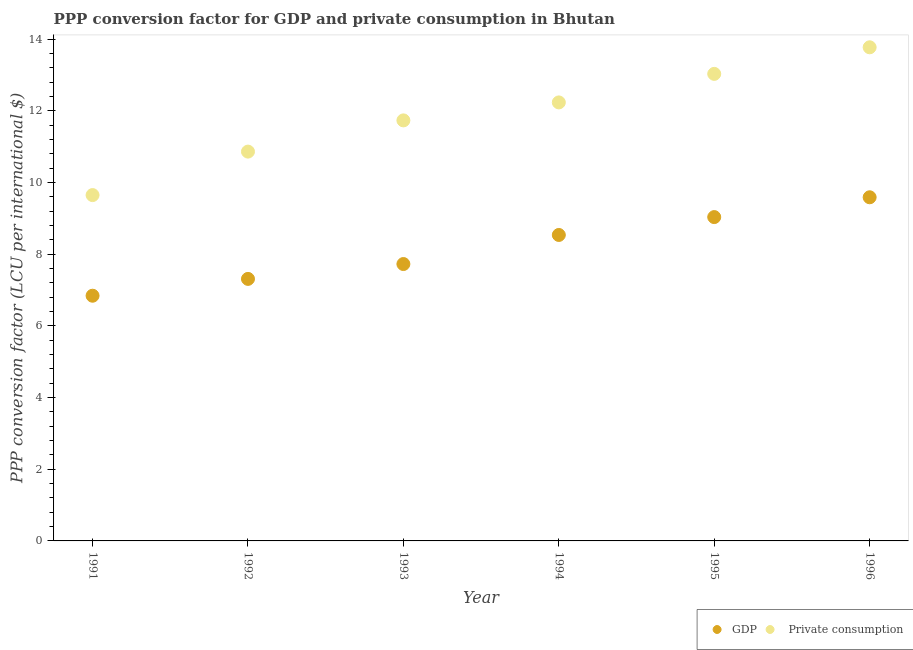How many different coloured dotlines are there?
Ensure brevity in your answer.  2. What is the ppp conversion factor for private consumption in 1994?
Offer a very short reply. 12.24. Across all years, what is the maximum ppp conversion factor for gdp?
Offer a very short reply. 9.59. Across all years, what is the minimum ppp conversion factor for gdp?
Offer a very short reply. 6.84. In which year was the ppp conversion factor for private consumption maximum?
Your response must be concise. 1996. What is the total ppp conversion factor for private consumption in the graph?
Ensure brevity in your answer.  71.3. What is the difference between the ppp conversion factor for private consumption in 1991 and that in 1993?
Keep it short and to the point. -2.08. What is the difference between the ppp conversion factor for gdp in 1995 and the ppp conversion factor for private consumption in 1992?
Give a very brief answer. -1.83. What is the average ppp conversion factor for gdp per year?
Make the answer very short. 8.17. In the year 1995, what is the difference between the ppp conversion factor for gdp and ppp conversion factor for private consumption?
Make the answer very short. -4. What is the ratio of the ppp conversion factor for gdp in 1992 to that in 1995?
Make the answer very short. 0.81. Is the ppp conversion factor for private consumption in 1993 less than that in 1996?
Provide a succinct answer. Yes. Is the difference between the ppp conversion factor for gdp in 1991 and 1993 greater than the difference between the ppp conversion factor for private consumption in 1991 and 1993?
Give a very brief answer. Yes. What is the difference between the highest and the second highest ppp conversion factor for gdp?
Offer a very short reply. 0.55. What is the difference between the highest and the lowest ppp conversion factor for private consumption?
Your answer should be compact. 4.12. In how many years, is the ppp conversion factor for gdp greater than the average ppp conversion factor for gdp taken over all years?
Ensure brevity in your answer.  3. Is the sum of the ppp conversion factor for gdp in 1993 and 1994 greater than the maximum ppp conversion factor for private consumption across all years?
Make the answer very short. Yes. Does the ppp conversion factor for gdp monotonically increase over the years?
Offer a terse response. Yes. Are the values on the major ticks of Y-axis written in scientific E-notation?
Provide a short and direct response. No. Does the graph contain any zero values?
Provide a short and direct response. No. Does the graph contain grids?
Provide a short and direct response. No. What is the title of the graph?
Your answer should be compact. PPP conversion factor for GDP and private consumption in Bhutan. What is the label or title of the X-axis?
Provide a short and direct response. Year. What is the label or title of the Y-axis?
Your response must be concise. PPP conversion factor (LCU per international $). What is the PPP conversion factor (LCU per international $) in GDP in 1991?
Provide a short and direct response. 6.84. What is the PPP conversion factor (LCU per international $) in  Private consumption in 1991?
Your answer should be very brief. 9.65. What is the PPP conversion factor (LCU per international $) in GDP in 1992?
Your answer should be compact. 7.31. What is the PPP conversion factor (LCU per international $) of  Private consumption in 1992?
Your response must be concise. 10.86. What is the PPP conversion factor (LCU per international $) of GDP in 1993?
Offer a terse response. 7.73. What is the PPP conversion factor (LCU per international $) of  Private consumption in 1993?
Offer a very short reply. 11.74. What is the PPP conversion factor (LCU per international $) of GDP in 1994?
Keep it short and to the point. 8.54. What is the PPP conversion factor (LCU per international $) of  Private consumption in 1994?
Provide a succinct answer. 12.24. What is the PPP conversion factor (LCU per international $) of GDP in 1995?
Make the answer very short. 9.04. What is the PPP conversion factor (LCU per international $) of  Private consumption in 1995?
Provide a succinct answer. 13.03. What is the PPP conversion factor (LCU per international $) in GDP in 1996?
Give a very brief answer. 9.59. What is the PPP conversion factor (LCU per international $) of  Private consumption in 1996?
Provide a short and direct response. 13.78. Across all years, what is the maximum PPP conversion factor (LCU per international $) of GDP?
Your response must be concise. 9.59. Across all years, what is the maximum PPP conversion factor (LCU per international $) in  Private consumption?
Ensure brevity in your answer.  13.78. Across all years, what is the minimum PPP conversion factor (LCU per international $) in GDP?
Offer a very short reply. 6.84. Across all years, what is the minimum PPP conversion factor (LCU per international $) of  Private consumption?
Keep it short and to the point. 9.65. What is the total PPP conversion factor (LCU per international $) of GDP in the graph?
Provide a succinct answer. 49.05. What is the total PPP conversion factor (LCU per international $) in  Private consumption in the graph?
Ensure brevity in your answer.  71.3. What is the difference between the PPP conversion factor (LCU per international $) of GDP in 1991 and that in 1992?
Give a very brief answer. -0.47. What is the difference between the PPP conversion factor (LCU per international $) in  Private consumption in 1991 and that in 1992?
Your answer should be very brief. -1.21. What is the difference between the PPP conversion factor (LCU per international $) in GDP in 1991 and that in 1993?
Give a very brief answer. -0.88. What is the difference between the PPP conversion factor (LCU per international $) of  Private consumption in 1991 and that in 1993?
Make the answer very short. -2.08. What is the difference between the PPP conversion factor (LCU per international $) of GDP in 1991 and that in 1994?
Give a very brief answer. -1.7. What is the difference between the PPP conversion factor (LCU per international $) in  Private consumption in 1991 and that in 1994?
Make the answer very short. -2.59. What is the difference between the PPP conversion factor (LCU per international $) of GDP in 1991 and that in 1995?
Your response must be concise. -2.19. What is the difference between the PPP conversion factor (LCU per international $) of  Private consumption in 1991 and that in 1995?
Provide a succinct answer. -3.38. What is the difference between the PPP conversion factor (LCU per international $) in GDP in 1991 and that in 1996?
Ensure brevity in your answer.  -2.75. What is the difference between the PPP conversion factor (LCU per international $) of  Private consumption in 1991 and that in 1996?
Keep it short and to the point. -4.12. What is the difference between the PPP conversion factor (LCU per international $) of GDP in 1992 and that in 1993?
Offer a very short reply. -0.41. What is the difference between the PPP conversion factor (LCU per international $) of  Private consumption in 1992 and that in 1993?
Offer a terse response. -0.87. What is the difference between the PPP conversion factor (LCU per international $) of GDP in 1992 and that in 1994?
Give a very brief answer. -1.23. What is the difference between the PPP conversion factor (LCU per international $) of  Private consumption in 1992 and that in 1994?
Ensure brevity in your answer.  -1.37. What is the difference between the PPP conversion factor (LCU per international $) in GDP in 1992 and that in 1995?
Your answer should be compact. -1.72. What is the difference between the PPP conversion factor (LCU per international $) in  Private consumption in 1992 and that in 1995?
Offer a terse response. -2.17. What is the difference between the PPP conversion factor (LCU per international $) of GDP in 1992 and that in 1996?
Offer a terse response. -2.28. What is the difference between the PPP conversion factor (LCU per international $) in  Private consumption in 1992 and that in 1996?
Your response must be concise. -2.91. What is the difference between the PPP conversion factor (LCU per international $) in GDP in 1993 and that in 1994?
Your answer should be very brief. -0.81. What is the difference between the PPP conversion factor (LCU per international $) of  Private consumption in 1993 and that in 1994?
Give a very brief answer. -0.5. What is the difference between the PPP conversion factor (LCU per international $) of GDP in 1993 and that in 1995?
Offer a very short reply. -1.31. What is the difference between the PPP conversion factor (LCU per international $) in  Private consumption in 1993 and that in 1995?
Your response must be concise. -1.3. What is the difference between the PPP conversion factor (LCU per international $) in GDP in 1993 and that in 1996?
Provide a succinct answer. -1.86. What is the difference between the PPP conversion factor (LCU per international $) in  Private consumption in 1993 and that in 1996?
Your answer should be compact. -2.04. What is the difference between the PPP conversion factor (LCU per international $) of GDP in 1994 and that in 1995?
Ensure brevity in your answer.  -0.5. What is the difference between the PPP conversion factor (LCU per international $) in  Private consumption in 1994 and that in 1995?
Your answer should be very brief. -0.8. What is the difference between the PPP conversion factor (LCU per international $) of GDP in 1994 and that in 1996?
Ensure brevity in your answer.  -1.05. What is the difference between the PPP conversion factor (LCU per international $) in  Private consumption in 1994 and that in 1996?
Provide a succinct answer. -1.54. What is the difference between the PPP conversion factor (LCU per international $) of GDP in 1995 and that in 1996?
Offer a terse response. -0.55. What is the difference between the PPP conversion factor (LCU per international $) of  Private consumption in 1995 and that in 1996?
Offer a terse response. -0.74. What is the difference between the PPP conversion factor (LCU per international $) in GDP in 1991 and the PPP conversion factor (LCU per international $) in  Private consumption in 1992?
Provide a succinct answer. -4.02. What is the difference between the PPP conversion factor (LCU per international $) in GDP in 1991 and the PPP conversion factor (LCU per international $) in  Private consumption in 1993?
Your answer should be compact. -4.89. What is the difference between the PPP conversion factor (LCU per international $) in GDP in 1991 and the PPP conversion factor (LCU per international $) in  Private consumption in 1994?
Offer a terse response. -5.39. What is the difference between the PPP conversion factor (LCU per international $) in GDP in 1991 and the PPP conversion factor (LCU per international $) in  Private consumption in 1995?
Your answer should be compact. -6.19. What is the difference between the PPP conversion factor (LCU per international $) in GDP in 1991 and the PPP conversion factor (LCU per international $) in  Private consumption in 1996?
Your answer should be very brief. -6.93. What is the difference between the PPP conversion factor (LCU per international $) of GDP in 1992 and the PPP conversion factor (LCU per international $) of  Private consumption in 1993?
Offer a terse response. -4.42. What is the difference between the PPP conversion factor (LCU per international $) of GDP in 1992 and the PPP conversion factor (LCU per international $) of  Private consumption in 1994?
Your answer should be very brief. -4.93. What is the difference between the PPP conversion factor (LCU per international $) of GDP in 1992 and the PPP conversion factor (LCU per international $) of  Private consumption in 1995?
Keep it short and to the point. -5.72. What is the difference between the PPP conversion factor (LCU per international $) in GDP in 1992 and the PPP conversion factor (LCU per international $) in  Private consumption in 1996?
Provide a short and direct response. -6.46. What is the difference between the PPP conversion factor (LCU per international $) of GDP in 1993 and the PPP conversion factor (LCU per international $) of  Private consumption in 1994?
Offer a very short reply. -4.51. What is the difference between the PPP conversion factor (LCU per international $) of GDP in 1993 and the PPP conversion factor (LCU per international $) of  Private consumption in 1995?
Provide a succinct answer. -5.31. What is the difference between the PPP conversion factor (LCU per international $) of GDP in 1993 and the PPP conversion factor (LCU per international $) of  Private consumption in 1996?
Provide a short and direct response. -6.05. What is the difference between the PPP conversion factor (LCU per international $) of GDP in 1994 and the PPP conversion factor (LCU per international $) of  Private consumption in 1995?
Ensure brevity in your answer.  -4.5. What is the difference between the PPP conversion factor (LCU per international $) in GDP in 1994 and the PPP conversion factor (LCU per international $) in  Private consumption in 1996?
Your answer should be compact. -5.24. What is the difference between the PPP conversion factor (LCU per international $) in GDP in 1995 and the PPP conversion factor (LCU per international $) in  Private consumption in 1996?
Make the answer very short. -4.74. What is the average PPP conversion factor (LCU per international $) of GDP per year?
Make the answer very short. 8.17. What is the average PPP conversion factor (LCU per international $) in  Private consumption per year?
Provide a short and direct response. 11.88. In the year 1991, what is the difference between the PPP conversion factor (LCU per international $) in GDP and PPP conversion factor (LCU per international $) in  Private consumption?
Your answer should be very brief. -2.81. In the year 1992, what is the difference between the PPP conversion factor (LCU per international $) of GDP and PPP conversion factor (LCU per international $) of  Private consumption?
Give a very brief answer. -3.55. In the year 1993, what is the difference between the PPP conversion factor (LCU per international $) in GDP and PPP conversion factor (LCU per international $) in  Private consumption?
Ensure brevity in your answer.  -4.01. In the year 1994, what is the difference between the PPP conversion factor (LCU per international $) in GDP and PPP conversion factor (LCU per international $) in  Private consumption?
Provide a succinct answer. -3.7. In the year 1995, what is the difference between the PPP conversion factor (LCU per international $) of GDP and PPP conversion factor (LCU per international $) of  Private consumption?
Give a very brief answer. -4. In the year 1996, what is the difference between the PPP conversion factor (LCU per international $) in GDP and PPP conversion factor (LCU per international $) in  Private consumption?
Your answer should be very brief. -4.19. What is the ratio of the PPP conversion factor (LCU per international $) in GDP in 1991 to that in 1992?
Your response must be concise. 0.94. What is the ratio of the PPP conversion factor (LCU per international $) in  Private consumption in 1991 to that in 1992?
Make the answer very short. 0.89. What is the ratio of the PPP conversion factor (LCU per international $) of GDP in 1991 to that in 1993?
Your response must be concise. 0.89. What is the ratio of the PPP conversion factor (LCU per international $) in  Private consumption in 1991 to that in 1993?
Keep it short and to the point. 0.82. What is the ratio of the PPP conversion factor (LCU per international $) in GDP in 1991 to that in 1994?
Offer a terse response. 0.8. What is the ratio of the PPP conversion factor (LCU per international $) of  Private consumption in 1991 to that in 1994?
Ensure brevity in your answer.  0.79. What is the ratio of the PPP conversion factor (LCU per international $) in GDP in 1991 to that in 1995?
Give a very brief answer. 0.76. What is the ratio of the PPP conversion factor (LCU per international $) of  Private consumption in 1991 to that in 1995?
Offer a terse response. 0.74. What is the ratio of the PPP conversion factor (LCU per international $) in GDP in 1991 to that in 1996?
Ensure brevity in your answer.  0.71. What is the ratio of the PPP conversion factor (LCU per international $) of  Private consumption in 1991 to that in 1996?
Offer a terse response. 0.7. What is the ratio of the PPP conversion factor (LCU per international $) in GDP in 1992 to that in 1993?
Ensure brevity in your answer.  0.95. What is the ratio of the PPP conversion factor (LCU per international $) of  Private consumption in 1992 to that in 1993?
Keep it short and to the point. 0.93. What is the ratio of the PPP conversion factor (LCU per international $) in GDP in 1992 to that in 1994?
Your answer should be compact. 0.86. What is the ratio of the PPP conversion factor (LCU per international $) of  Private consumption in 1992 to that in 1994?
Make the answer very short. 0.89. What is the ratio of the PPP conversion factor (LCU per international $) in GDP in 1992 to that in 1995?
Provide a succinct answer. 0.81. What is the ratio of the PPP conversion factor (LCU per international $) of  Private consumption in 1992 to that in 1995?
Provide a short and direct response. 0.83. What is the ratio of the PPP conversion factor (LCU per international $) in GDP in 1992 to that in 1996?
Ensure brevity in your answer.  0.76. What is the ratio of the PPP conversion factor (LCU per international $) in  Private consumption in 1992 to that in 1996?
Keep it short and to the point. 0.79. What is the ratio of the PPP conversion factor (LCU per international $) of GDP in 1993 to that in 1994?
Your response must be concise. 0.91. What is the ratio of the PPP conversion factor (LCU per international $) in GDP in 1993 to that in 1995?
Offer a terse response. 0.85. What is the ratio of the PPP conversion factor (LCU per international $) of  Private consumption in 1993 to that in 1995?
Your answer should be compact. 0.9. What is the ratio of the PPP conversion factor (LCU per international $) in GDP in 1993 to that in 1996?
Make the answer very short. 0.81. What is the ratio of the PPP conversion factor (LCU per international $) in  Private consumption in 1993 to that in 1996?
Offer a very short reply. 0.85. What is the ratio of the PPP conversion factor (LCU per international $) of GDP in 1994 to that in 1995?
Offer a terse response. 0.94. What is the ratio of the PPP conversion factor (LCU per international $) in  Private consumption in 1994 to that in 1995?
Your response must be concise. 0.94. What is the ratio of the PPP conversion factor (LCU per international $) of GDP in 1994 to that in 1996?
Provide a short and direct response. 0.89. What is the ratio of the PPP conversion factor (LCU per international $) in  Private consumption in 1994 to that in 1996?
Your answer should be very brief. 0.89. What is the ratio of the PPP conversion factor (LCU per international $) in GDP in 1995 to that in 1996?
Your answer should be compact. 0.94. What is the ratio of the PPP conversion factor (LCU per international $) of  Private consumption in 1995 to that in 1996?
Provide a short and direct response. 0.95. What is the difference between the highest and the second highest PPP conversion factor (LCU per international $) in GDP?
Keep it short and to the point. 0.55. What is the difference between the highest and the second highest PPP conversion factor (LCU per international $) in  Private consumption?
Your answer should be compact. 0.74. What is the difference between the highest and the lowest PPP conversion factor (LCU per international $) in GDP?
Make the answer very short. 2.75. What is the difference between the highest and the lowest PPP conversion factor (LCU per international $) of  Private consumption?
Your answer should be very brief. 4.12. 